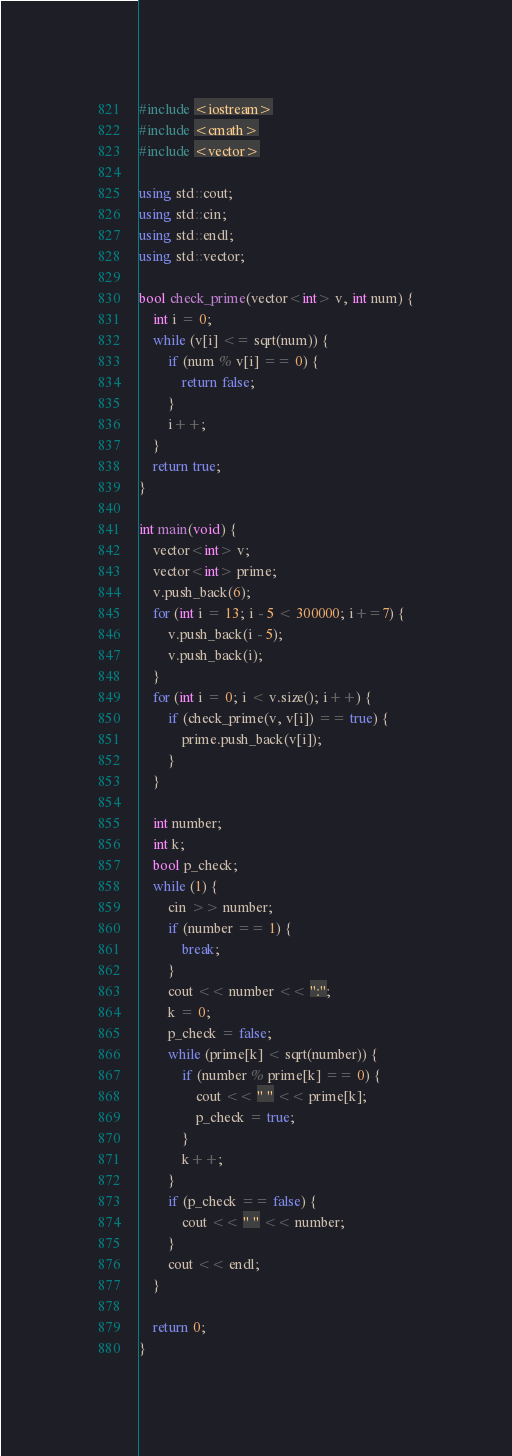<code> <loc_0><loc_0><loc_500><loc_500><_C++_>#include <iostream>
#include <cmath>
#include <vector>

using std::cout;
using std::cin;
using std::endl;
using std::vector;

bool check_prime(vector<int> v, int num) {
    int i = 0;
    while (v[i] <= sqrt(num)) {
        if (num % v[i] == 0) {
            return false; 
        }
        i++;
    }
    return true;
}

int main(void) {
    vector<int> v;
    vector<int> prime;
    v.push_back(6); 
    for (int i = 13; i - 5 < 300000; i+=7) {
        v.push_back(i - 5); 
        v.push_back(i); 
    }
    for (int i = 0; i < v.size(); i++) {
        if (check_prime(v, v[i]) == true) {
            prime.push_back(v[i]); 
        }
    }

    int number;
    int k;
    bool p_check;
    while (1) {
        cin >> number;
        if (number == 1) {
            break;
        }
        cout << number << ":"; 
        k = 0; 
        p_check = false;
        while (prime[k] < sqrt(number)) {
            if (number % prime[k] == 0) {
                cout << " " << prime[k];
                p_check = true;
            }
            k++;
        }
        if (p_check == false) {
            cout << " " << number;
        }
        cout << endl;
    }

    return 0;
}</code> 